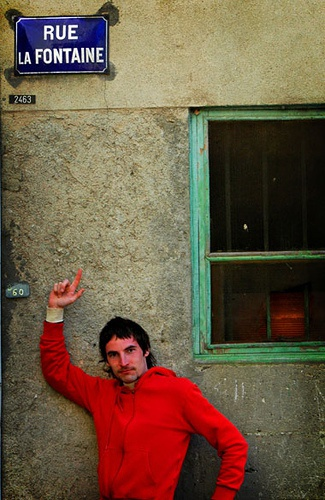Describe the objects in this image and their specific colors. I can see people in olive, brown, red, maroon, and black tones in this image. 